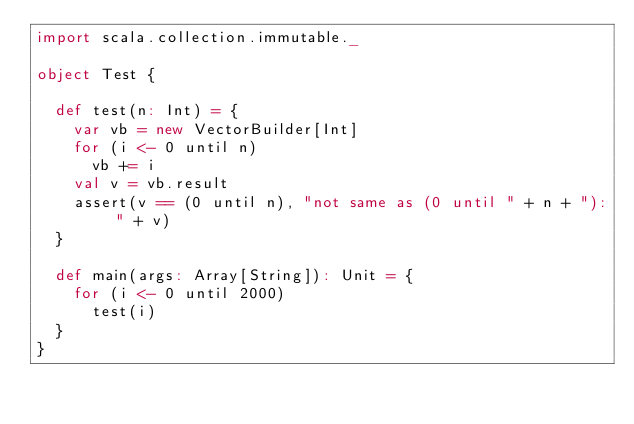Convert code to text. <code><loc_0><loc_0><loc_500><loc_500><_Scala_>import scala.collection.immutable._

object Test {

  def test(n: Int) = {
    var vb = new VectorBuilder[Int]
    for (i <- 0 until n)
      vb += i
    val v = vb.result
    assert(v == (0 until n), "not same as (0 until " + n + "): " + v)
  }

  def main(args: Array[String]): Unit = {
    for (i <- 0 until 2000)
      test(i)
  }
}
</code> 